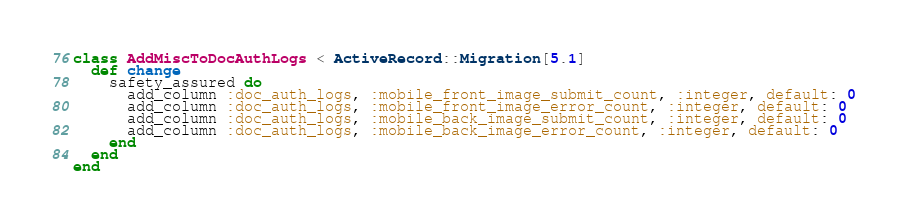Convert code to text. <code><loc_0><loc_0><loc_500><loc_500><_Ruby_>class AddMiscToDocAuthLogs < ActiveRecord::Migration[5.1]
  def change
    safety_assured do
      add_column :doc_auth_logs, :mobile_front_image_submit_count, :integer, default: 0
      add_column :doc_auth_logs, :mobile_front_image_error_count, :integer, default: 0
      add_column :doc_auth_logs, :mobile_back_image_submit_count, :integer, default: 0
      add_column :doc_auth_logs, :mobile_back_image_error_count, :integer, default: 0
    end
  end
end
</code> 